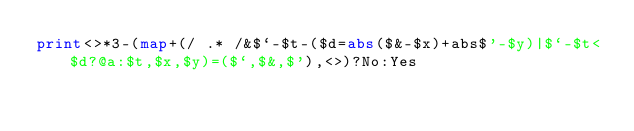<code> <loc_0><loc_0><loc_500><loc_500><_Perl_>print<>*3-(map+(/ .* /&$`-$t-($d=abs($&-$x)+abs$'-$y)|$`-$t<$d?@a:$t,$x,$y)=($`,$&,$'),<>)?No:Yes</code> 